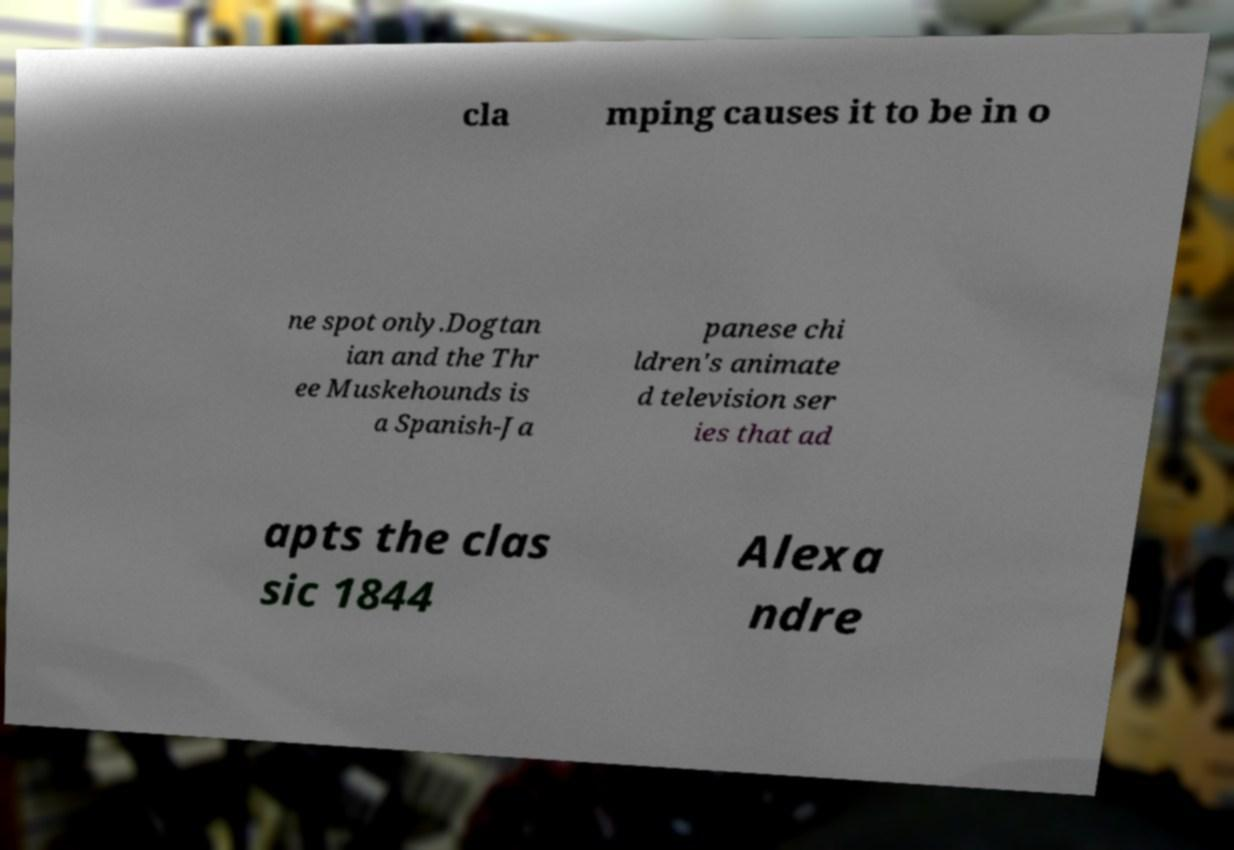Could you extract and type out the text from this image? cla mping causes it to be in o ne spot only.Dogtan ian and the Thr ee Muskehounds is a Spanish-Ja panese chi ldren's animate d television ser ies that ad apts the clas sic 1844 Alexa ndre 